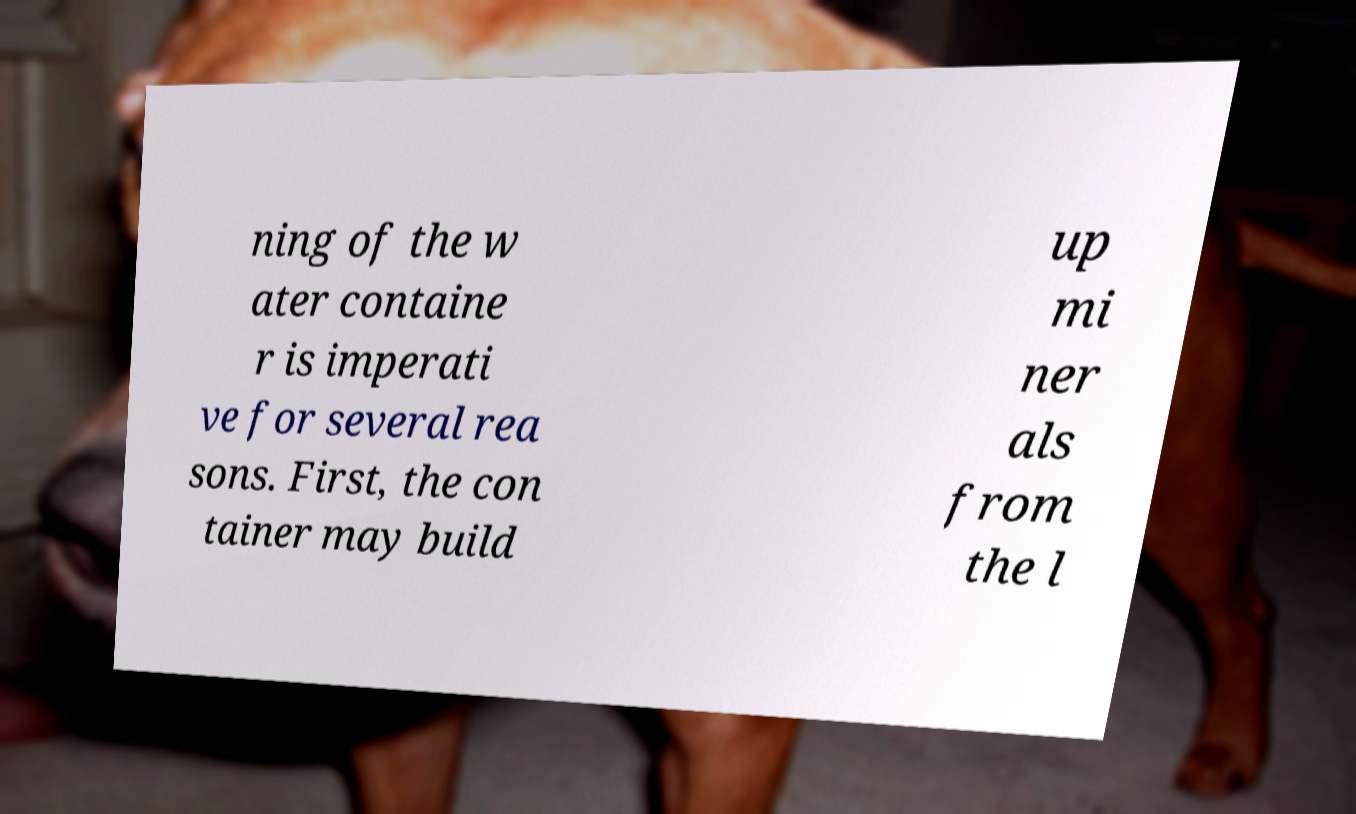Could you assist in decoding the text presented in this image and type it out clearly? ning of the w ater containe r is imperati ve for several rea sons. First, the con tainer may build up mi ner als from the l 